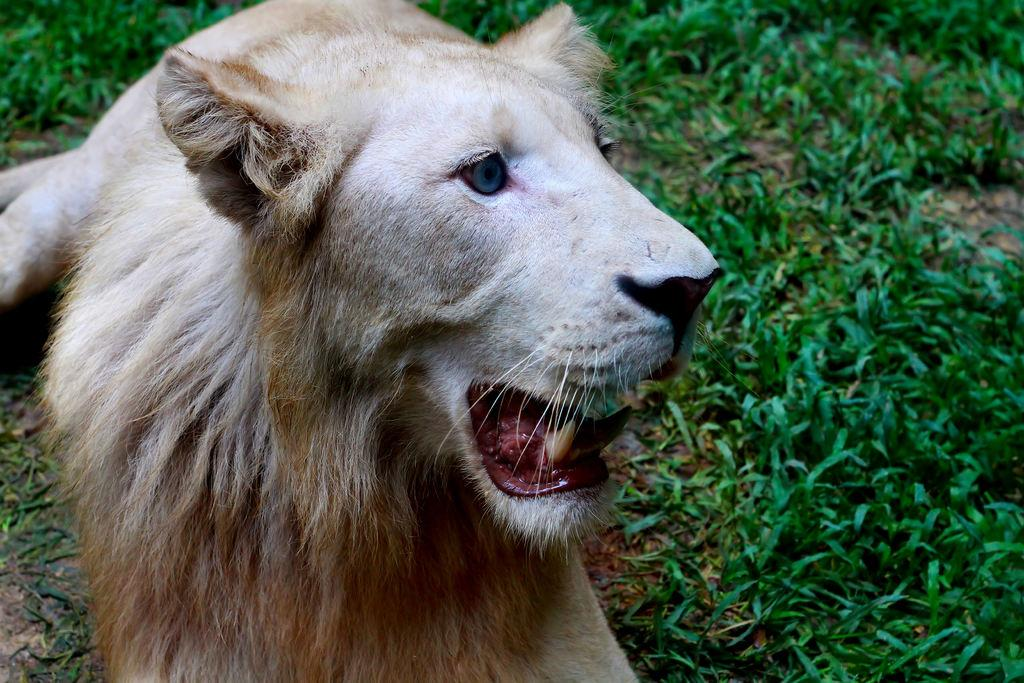What animal is the main subject of the image? There is a lion in the image. What type of environment is the lion in? There is grass behind the lion, suggesting a natural setting. Where is the lion's hand in the image? Lions do not have hands; they have paws. Additionally, there is no hand visible in the image. 